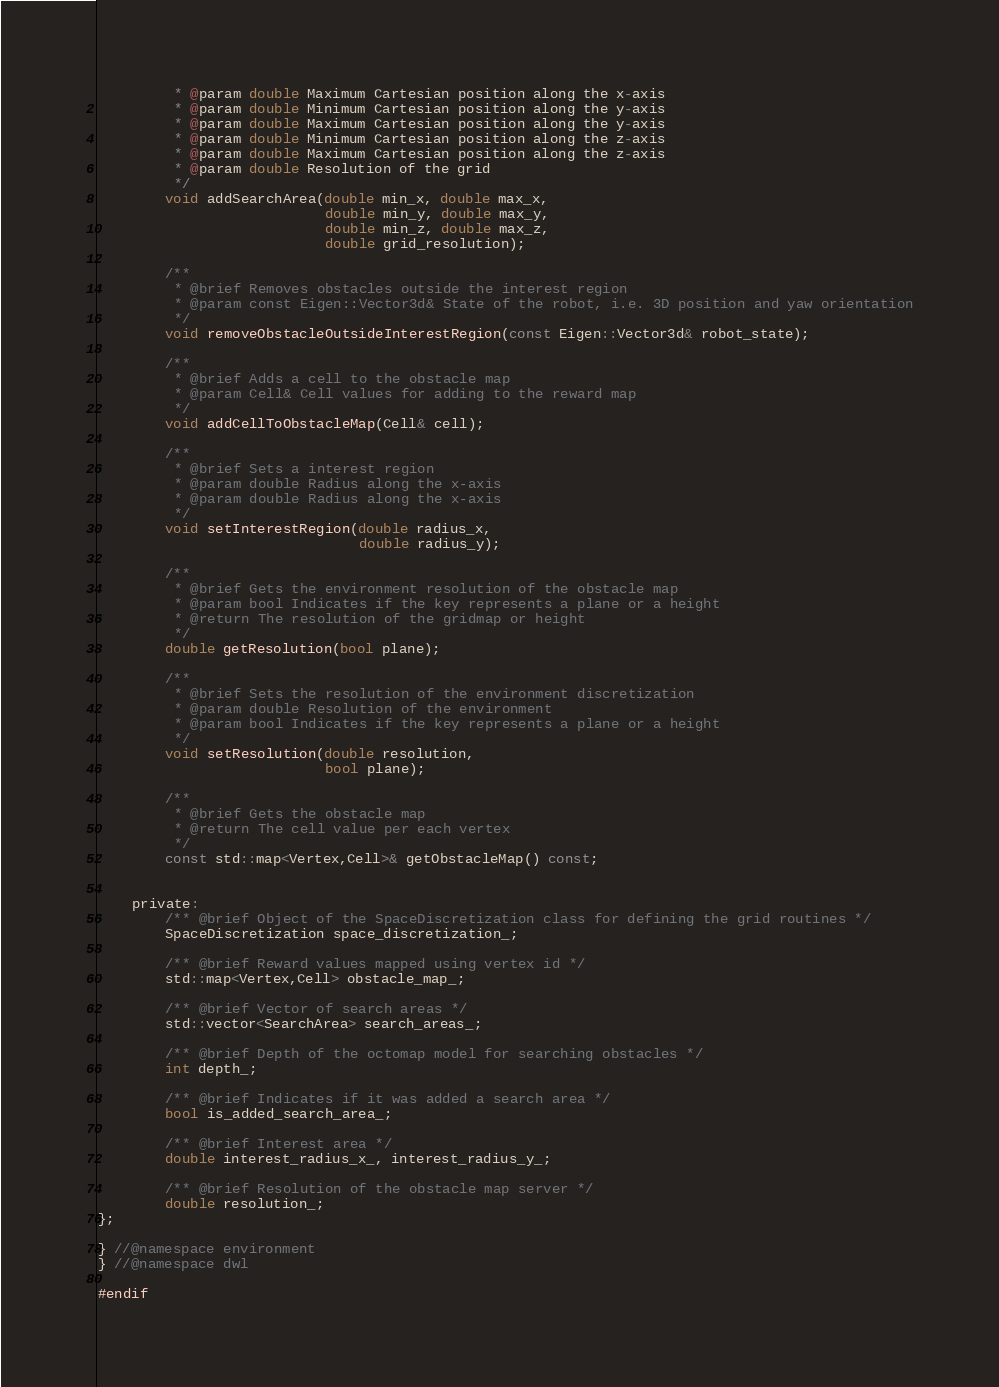Convert code to text. <code><loc_0><loc_0><loc_500><loc_500><_C_>		 * @param double Maximum Cartesian position along the x-axis
		 * @param double Minimum Cartesian position along the y-axis
		 * @param double Maximum Cartesian position along the y-axis
		 * @param double Minimum Cartesian position along the z-axis
		 * @param double Maximum Cartesian position along the z-axis
		 * @param double Resolution of the grid
		 */
		void addSearchArea(double min_x, double max_x,
						   double min_y, double max_y,
						   double min_z, double max_z,
						   double grid_resolution);

		/**
		 * @brief Removes obstacles outside the interest region
		 * @param const Eigen::Vector3d& State of the robot, i.e. 3D position and yaw orientation
		 */
		void removeObstacleOutsideInterestRegion(const Eigen::Vector3d& robot_state);

		/**
		 * @brief Adds a cell to the obstacle map
		 * @param Cell& Cell values for adding to the reward map
		 */
		void addCellToObstacleMap(Cell& cell);

		/**
		 * @brief Sets a interest region
		 * @param double Radius along the x-axis
		 * @param double Radius along the x-axis
		 */
		void setInterestRegion(double radius_x,
							   double radius_y);

		/**
		 * @brief Gets the environment resolution of the obstacle map
		 * @param bool Indicates if the key represents a plane or a height
		 * @return The resolution of the gridmap or height
		 */
		double getResolution(bool plane);

		/**
		 * @brief Sets the resolution of the environment discretization
		 * @param double Resolution of the environment
		 * @param bool Indicates if the key represents a plane or a height
		 */
		void setResolution(double resolution,
						   bool plane);

		/**
		 * @brief Gets the obstacle map
		 * @return The cell value per each vertex
		 */
		const std::map<Vertex,Cell>& getObstacleMap() const;


	private:
		/** @brief Object of the SpaceDiscretization class for defining the grid routines */
		SpaceDiscretization space_discretization_;

		/** @brief Reward values mapped using vertex id */
		std::map<Vertex,Cell> obstacle_map_;

		/** @brief Vector of search areas */
		std::vector<SearchArea> search_areas_;

		/** @brief Depth of the octomap model for searching obstacles */
		int depth_;

		/** @brief Indicates if it was added a search area */
		bool is_added_search_area_;

		/** @brief Interest area */
		double interest_radius_x_, interest_radius_y_;

		/** @brief Resolution of the obstacle map server */
		double resolution_;
};

} //@namespace environment
} //@namespace dwl

#endif
</code> 